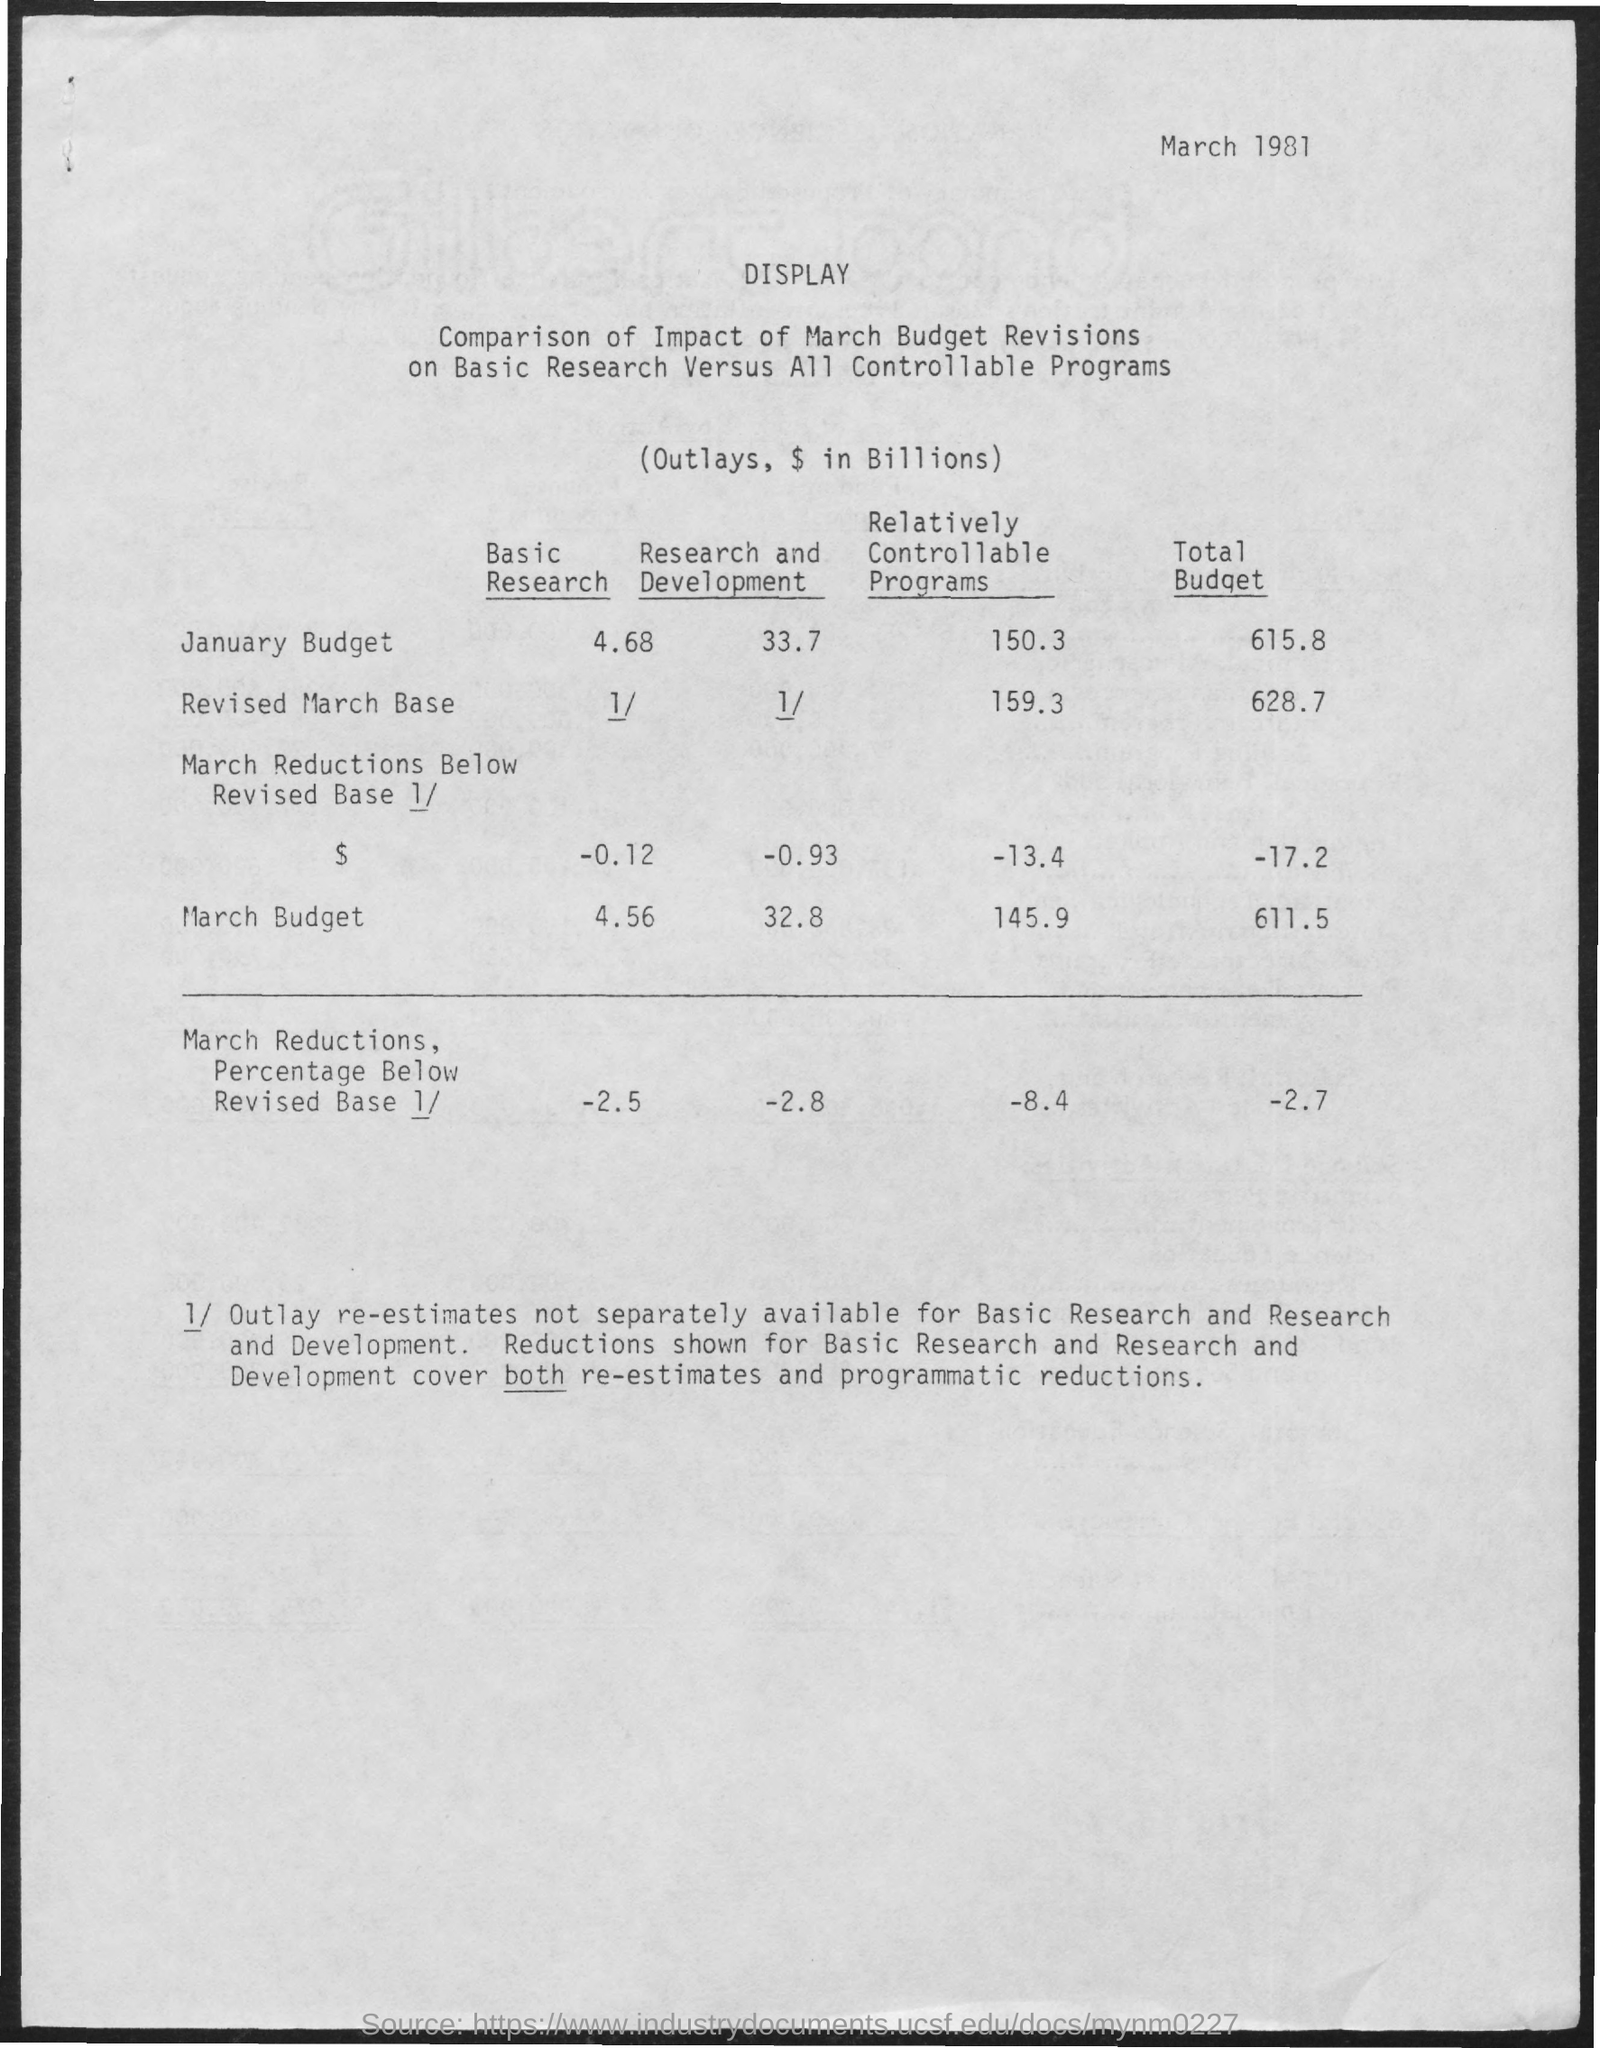Indicate a few pertinent items in this graphic. The total budget for March is 611.5... What are the controllable programs for the January budget? The total expenses for the month are 150.3. The total budget for the revised March base is 628.7. What is relatively controllable programs for March budget? 145.9 million dollars. What are the relatively controllable programs for the revised March base of 159.3? 